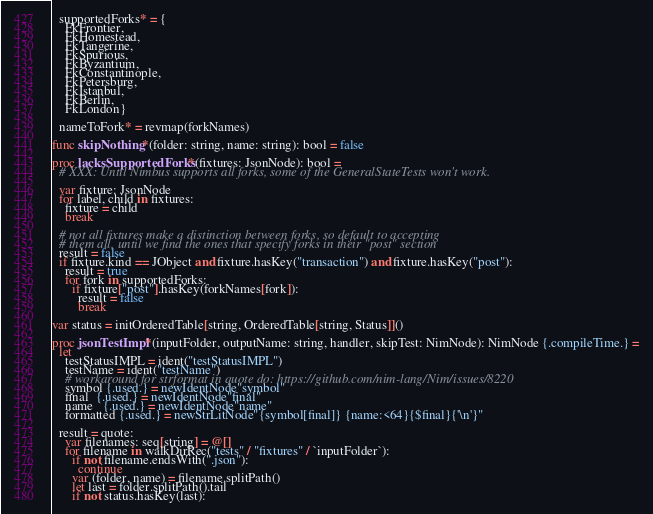<code> <loc_0><loc_0><loc_500><loc_500><_Nim_>  supportedForks* = {
    FkFrontier,
    FkHomestead,
    FkTangerine,
    FkSpurious,
    FkByzantium,
    FkConstantinople,
    FkPetersburg,
    FkIstanbul,
    FkBerlin,
    FkLondon}

  nameToFork* = revmap(forkNames)

func skipNothing*(folder: string, name: string): bool = false

proc lacksSupportedForks*(fixtures: JsonNode): bool =
  # XXX: Until Nimbus supports all forks, some of the GeneralStateTests won't work.

  var fixture: JsonNode
  for label, child in fixtures:
    fixture = child
    break

  # not all fixtures make a distinction between forks, so default to accepting
  # them all, until we find the ones that specify forks in their "post" section
  result = false
  if fixture.kind == JObject and fixture.hasKey("transaction") and fixture.hasKey("post"):
    result = true
    for fork in supportedForks:
      if fixture["post"].hasKey(forkNames[fork]):
        result = false
        break

var status = initOrderedTable[string, OrderedTable[string, Status]]()

proc jsonTestImpl*(inputFolder, outputName: string, handler, skipTest: NimNode): NimNode {.compileTime.} =
  let
    testStatusIMPL = ident("testStatusIMPL")
    testName = ident("testName")
    # workaround for strformat in quote do: https://github.com/nim-lang/Nim/issues/8220
    symbol {.used.} = newIdentNode"symbol"
    final  {.used.} = newIdentNode"final"
    name   {.used.} = newIdentNode"name"
    formatted {.used.} = newStrLitNode"{symbol[final]} {name:<64}{$final}{'\n'}"

  result = quote:
    var filenames: seq[string] = @[]
    for filename in walkDirRec("tests" / "fixtures" / `inputFolder`):
      if not filename.endsWith(".json"):
        continue
      var (folder, name) = filename.splitPath()
      let last = folder.splitPath().tail
      if not status.hasKey(last):</code> 